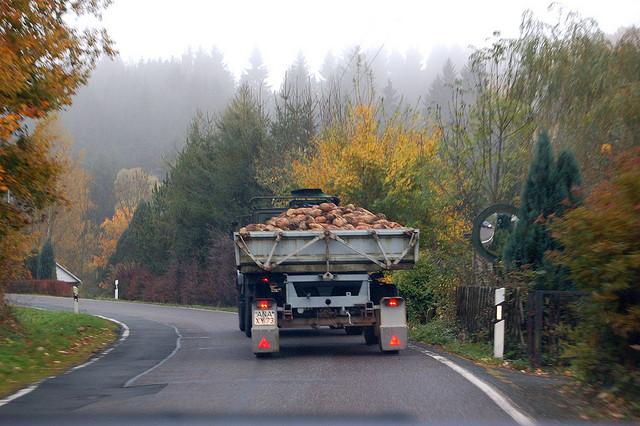How many vehicles are in the picture?
Concise answer only. 1. Does this look like a recently paved road?
Write a very short answer. Yes. Is this a steam engine?
Write a very short answer. No. Is this a paved road?
Short answer required. Yes. What color are the triangles on the truck?
Quick response, please. Orange. Which way does the road curve, to the left  or right?
Answer briefly. Left. Is the road paved?
Answer briefly. Yes. What is the truck carrying?
Be succinct. Rocks. How many cars do you see?
Concise answer only. 1. What color is the vehicle featured in this picture?
Write a very short answer. Gray. Does this look like a children's ride?
Keep it brief. No. What is the train going through?
Write a very short answer. No train. Can the engine go further left?
Concise answer only. Yes. Is it likely that a number of the car owners are fans of the alternate form of vehicle shown here?
Answer briefly. No. What vehicle is that?
Keep it brief. Truck. What is the truck hauling?
Quick response, please. Rocks. Is this a busy street?
Give a very brief answer. No. What is the truck transporting?
Answer briefly. Logs. 